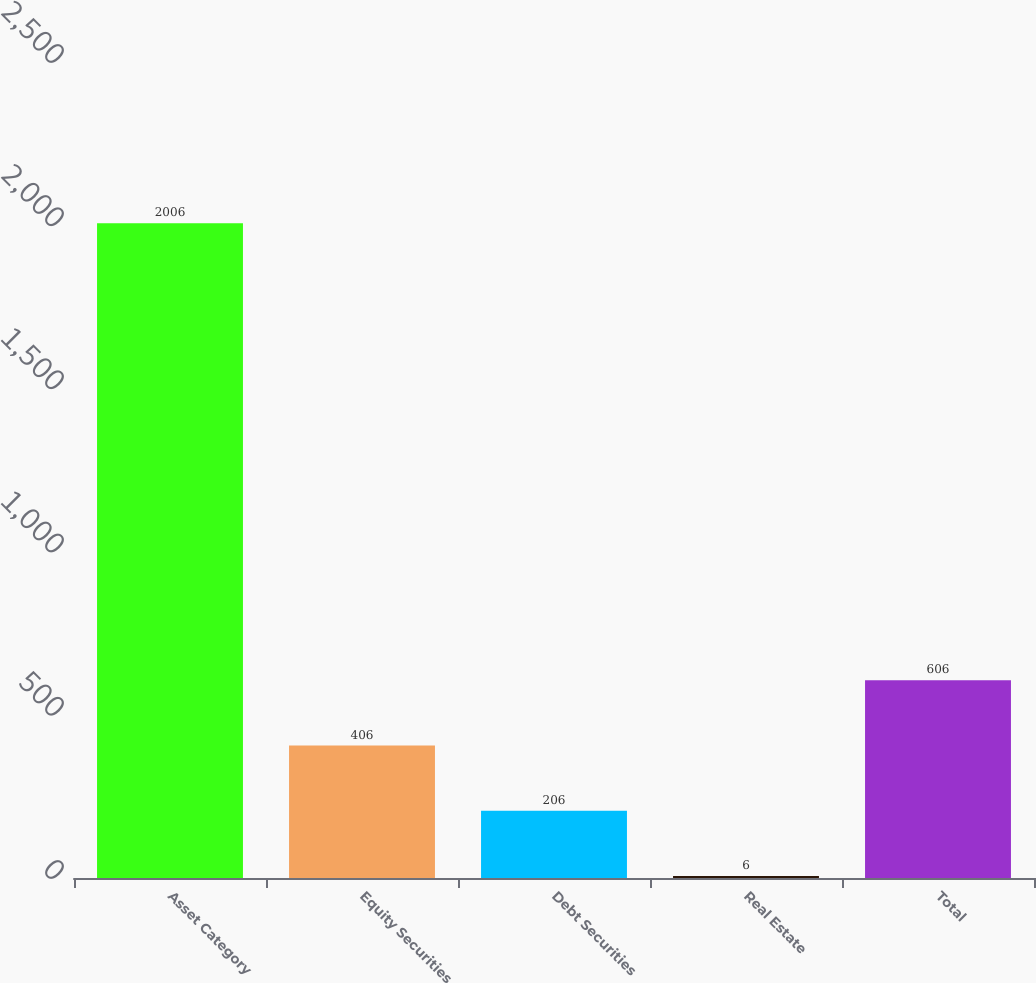Convert chart. <chart><loc_0><loc_0><loc_500><loc_500><bar_chart><fcel>Asset Category<fcel>Equity Securities<fcel>Debt Securities<fcel>Real Estate<fcel>Total<nl><fcel>2006<fcel>406<fcel>206<fcel>6<fcel>606<nl></chart> 